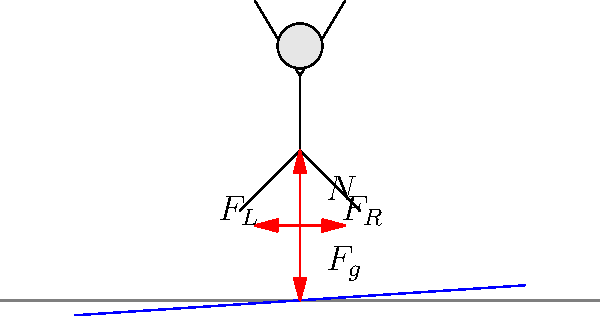As a parent concerned about safety, you're discussing the physics of slacklining with your child. Looking at the diagram of forces acting on a person balancing on a slackline, which force is primarily responsible for maintaining the person's balance and preventing them from falling off? Let's analyze the forces acting on the person balancing on the slackline:

1. $F_g$ (Gravity): This downward force is always present due to Earth's gravitational pull.

2. $N$ (Normal force): This upward force is the reaction force from the slackline, counteracting gravity.

3. $F_L$ and $F_R$ (Lateral forces): These horizontal forces act on the person's feet from the tension in the slackline.

To maintain balance:
a) The vertical forces must be balanced: $N = F_g$
b) The horizontal forces must be balanced: $F_L = F_R$

The key to maintaining balance is the ability to adjust the lateral forces $F_L$ and $F_R$. By shifting their body weight and making small adjustments with their feet, the person can control these forces to keep their center of mass above the slackline.

While all forces play a role, the lateral forces ($F_L$ and $F_R$) are primarily responsible for maintaining balance. They allow the person to make constant micro-adjustments to stay centered on the line.
Answer: Lateral forces ($F_L$ and $F_R$) 